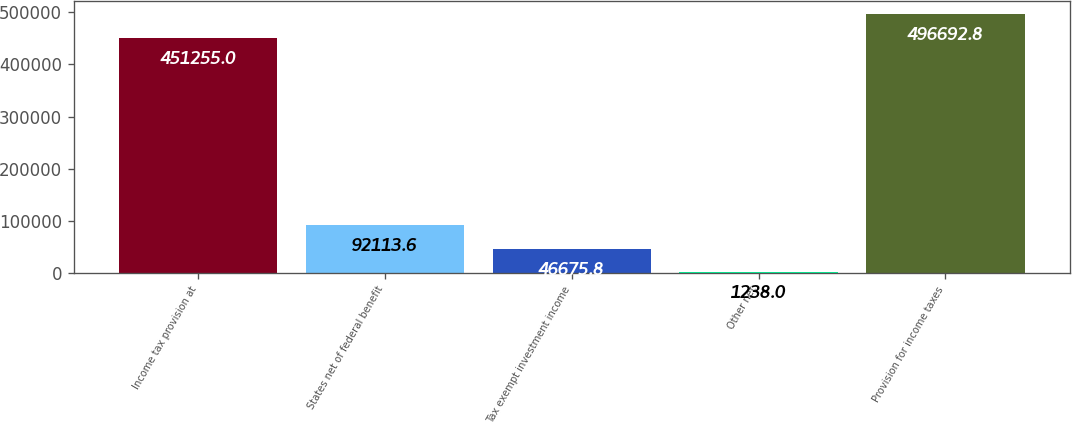Convert chart. <chart><loc_0><loc_0><loc_500><loc_500><bar_chart><fcel>Income tax provision at<fcel>States net of federal benefit<fcel>Tax exempt investment income<fcel>Other net<fcel>Provision for income taxes<nl><fcel>451255<fcel>92113.6<fcel>46675.8<fcel>1238<fcel>496693<nl></chart> 